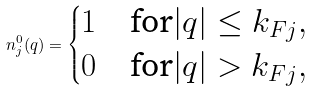<formula> <loc_0><loc_0><loc_500><loc_500>n ^ { 0 } _ { j } ( q ) = \begin{cases} 1 & \text {for} | q | \leq k _ { F j } , \\ 0 & \text {for} | q | > k _ { F j } , \end{cases}</formula> 